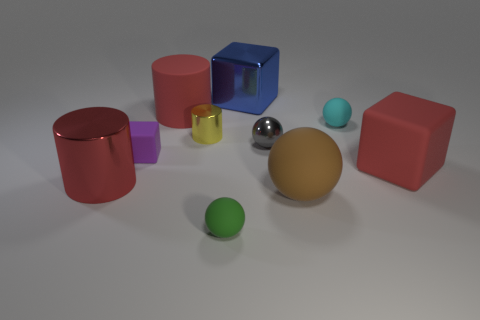Subtract 1 cubes. How many cubes are left? 2 Subtract all blocks. How many objects are left? 7 Subtract 0 yellow balls. How many objects are left? 10 Subtract all tiny cyan spheres. Subtract all brown spheres. How many objects are left? 8 Add 2 big red metal cylinders. How many big red metal cylinders are left? 3 Add 8 tiny cylinders. How many tiny cylinders exist? 9 